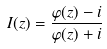Convert formula to latex. <formula><loc_0><loc_0><loc_500><loc_500>I ( z ) = \frac { \varphi ( z ) - i } { \varphi ( z ) + i }</formula> 